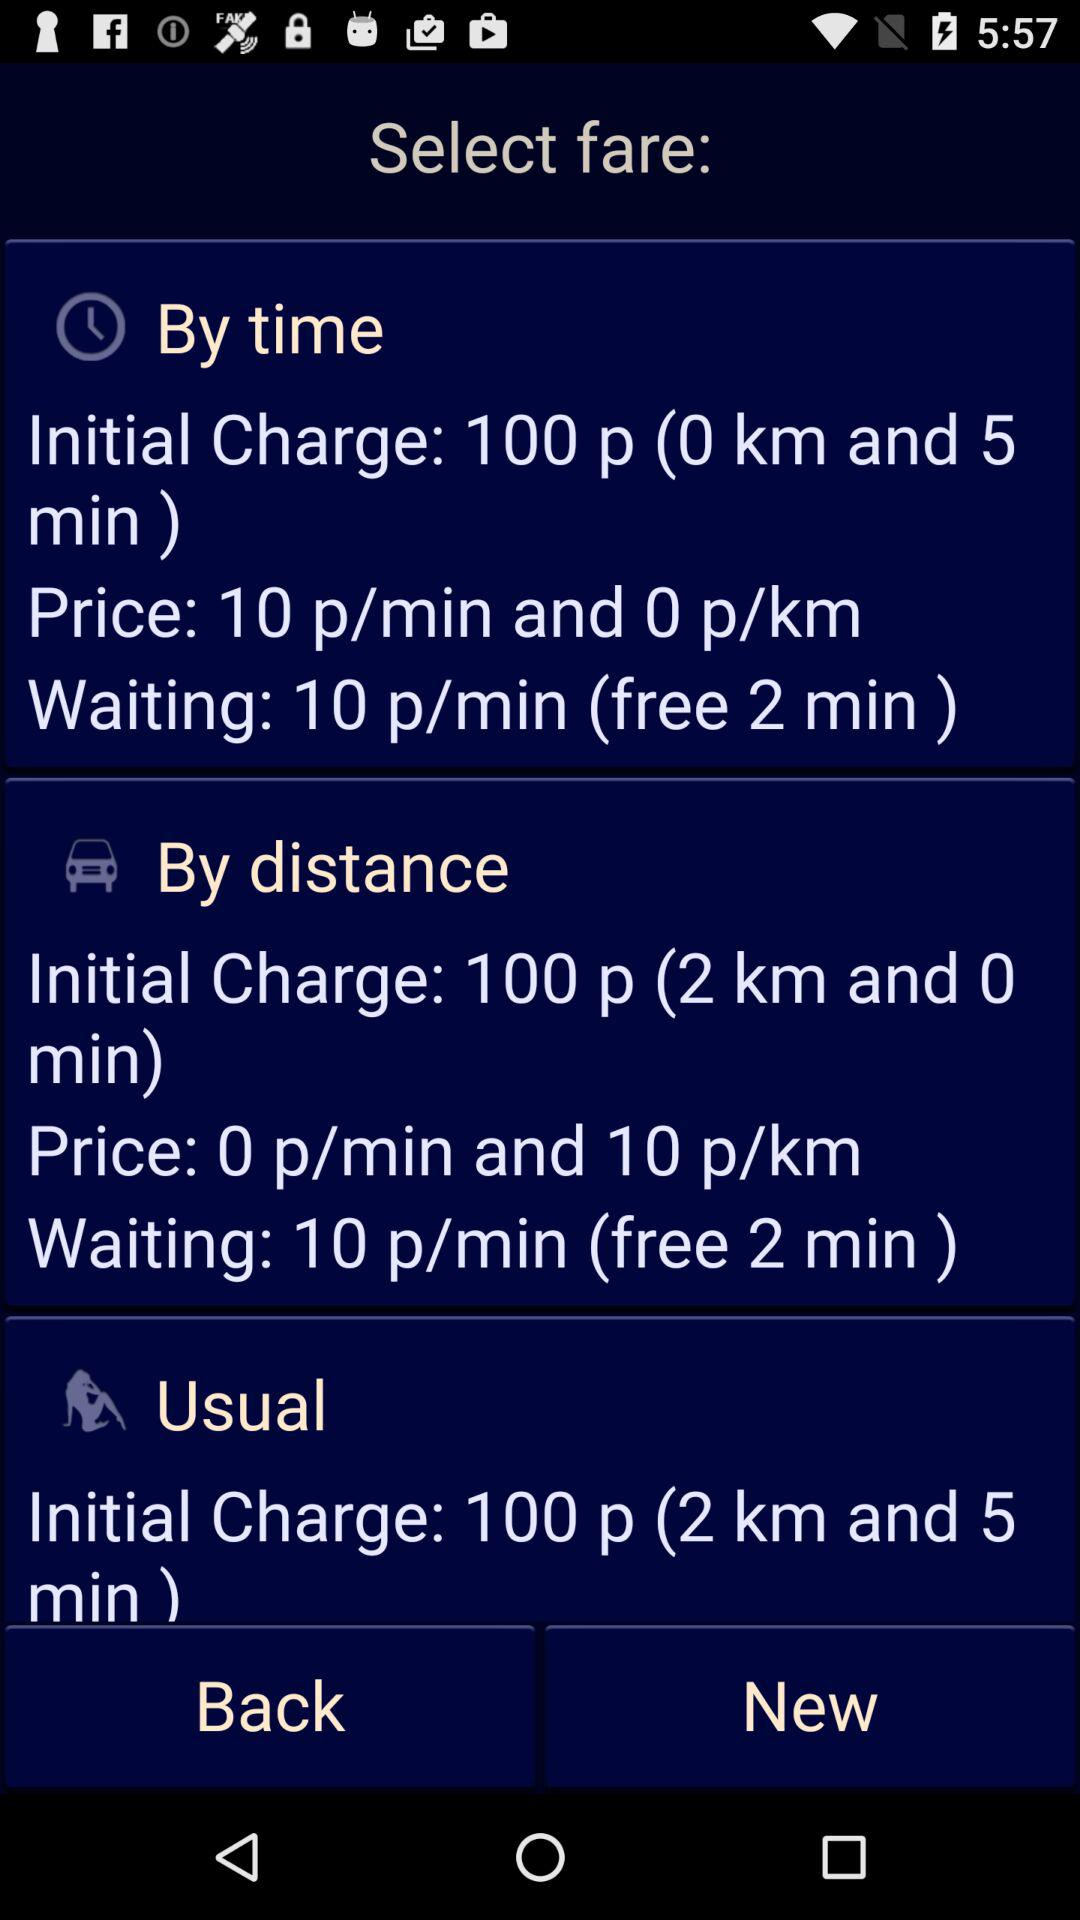What is the initial charge if travel by distance? The initial charge is 100 p (2 km and 0 min). 